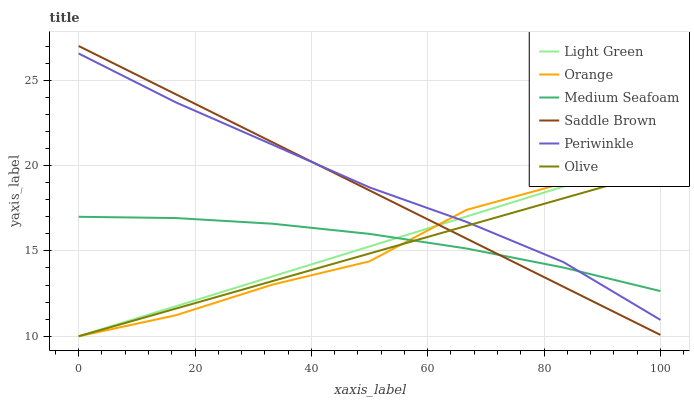Does Olive have the minimum area under the curve?
Answer yes or no. Yes. Does Periwinkle have the maximum area under the curve?
Answer yes or no. Yes. Does Periwinkle have the minimum area under the curve?
Answer yes or no. No. Does Olive have the maximum area under the curve?
Answer yes or no. No. Is Saddle Brown the smoothest?
Answer yes or no. Yes. Is Orange the roughest?
Answer yes or no. Yes. Is Olive the smoothest?
Answer yes or no. No. Is Olive the roughest?
Answer yes or no. No. Does Periwinkle have the lowest value?
Answer yes or no. No. Does Saddle Brown have the highest value?
Answer yes or no. Yes. Does Olive have the highest value?
Answer yes or no. No. 